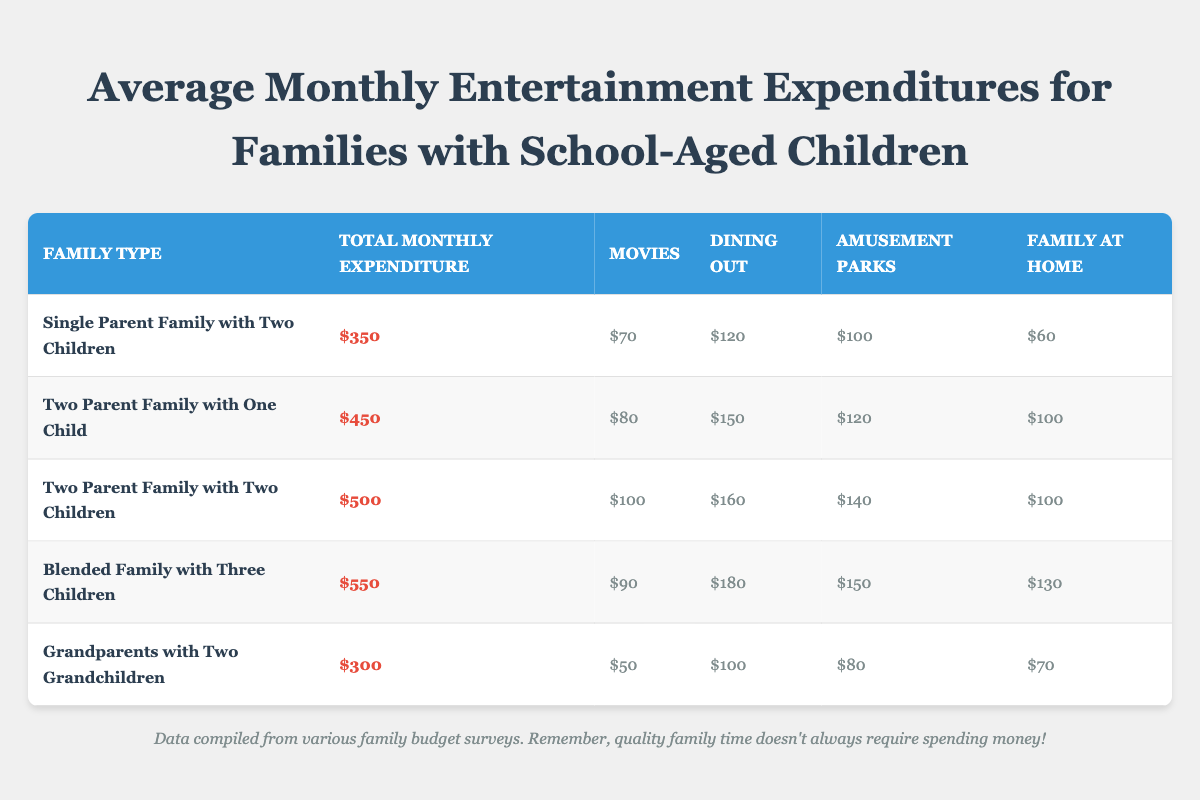What is the total monthly expenditure for a Blended Family with Three Children? The table lists the monthly expenditure for a Blended Family with Three Children as $550.
Answer: $550 Which family type spends the least on entertainment? The Grandparents with Two Grandchildren have the lowest monthly expenditure at $300.
Answer: Grandparents with Two Grandchildren What is the combined expenditure on dining out for the Two Parent Families? For the Two Parent Family with One Child, the expenditure on dining out is $150, and for the Two Parent Family with Two Children, it's $160. The total is $150 + $160 = $310.
Answer: $310 Is it true that Single Parent Families spend more on movies than Grandparents with Two Grandchildren? The Single Parent Family with Two Children spends $70 on movies while Grandparents with Two Grandchildren spend only $50. Since $70 is greater than $50, the statement is true.
Answer: Yes What is the average monthly expenditure on entertainment for all family types listed in the table? The total monthly expenditures add up to $350 + $450 + $500 + $550 + $300 = $2150. There are 5 family types, so the average is $2150 divided by 5, which equals $430.
Answer: $430 What is the difference in monthly expenditure between Blended Families and Two Parent Families with Two Children? The Blended Family with Three Children has an expenditure of $550, and the Two Parent Family with Two Children has an expenditure of $500. The difference is $550 - $500 = $50.
Answer: $50 How much do families spend on amusement parks compared to family time at home? For amusement parks, expenditures are $100 (Single Parent), $120 (Two Parent with One Child), $140 (Two Parent with Two Children), $150 (Blended Family), and $80 (Grandparents). Summing these gives $690. For family at home, they spend $60, $100, $100, $130, and $70, which totals $460. So, they spend $690 - $460 = $230 more on amusement parks.
Answer: $230 more Do Two Parent Families spend equally on dining out compared to Single Parent Families? Two Parent Families (with one child and two children) spend a combined total of $150 + $160 = $310 on dining out, while Single Parent Families spend only $120. This shows that Two Parent Families spend more.
Answer: No Which expenditure category has the highest total among all family types, and what is that total? Summing each category: Movies: $70 + $80 + $100 + $90 + $50 = $390; Dining Out: $120 + $150 + $160 + $180 + $100 = $810; Amusement Parks: $100 + $120 + $140 + $150 + $80 = $690; Family at Home: $60 + $100 + $100 + $130 + $70 = $460. Dining Out has the highest total, which is $810.
Answer: $810 